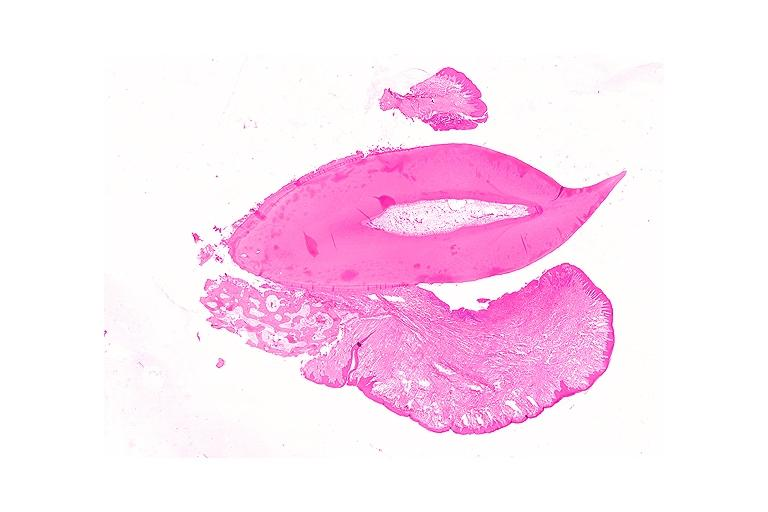does % show periodontal fibroma?
Answer the question using a single word or phrase. No 